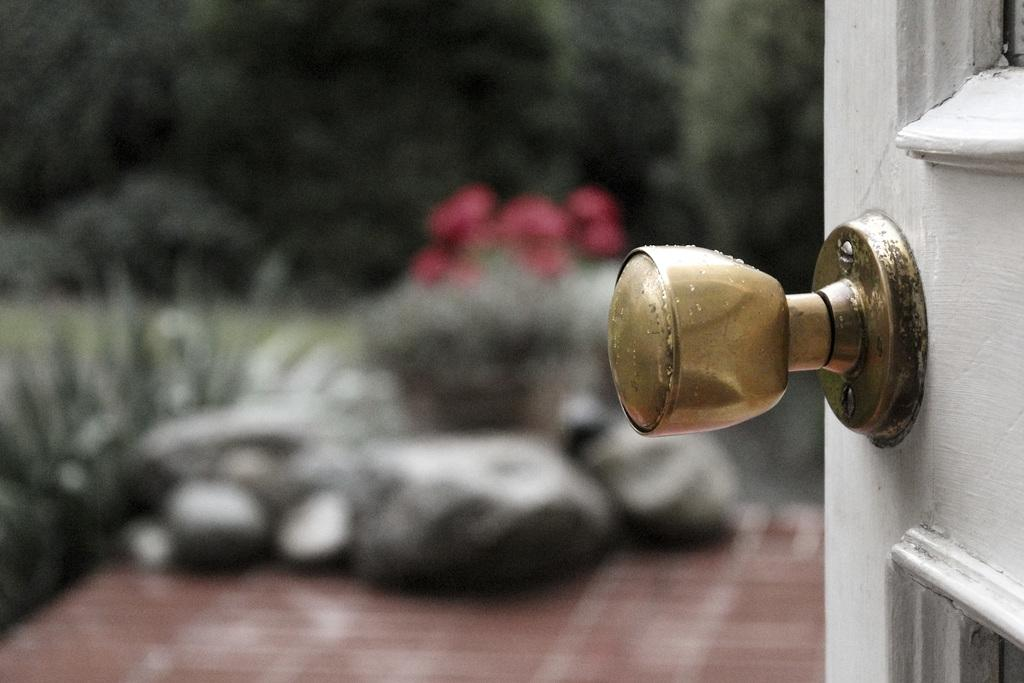What is present in the image that can be used for entering or exiting a space? There is a door in the image. What feature is present on the door? The door has a knob. What can be seen in the background of the image? There are trees and plants in the background of the image. How many spiders are crawling on the door in the image? There are no spiders visible on the door in the image. What type of stick is leaning against the door in the image? There is no stick present in the image. 